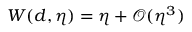Convert formula to latex. <formula><loc_0><loc_0><loc_500><loc_500>W ( d , \eta ) = \eta + \mathcal { O } ( \eta ^ { 3 } )</formula> 